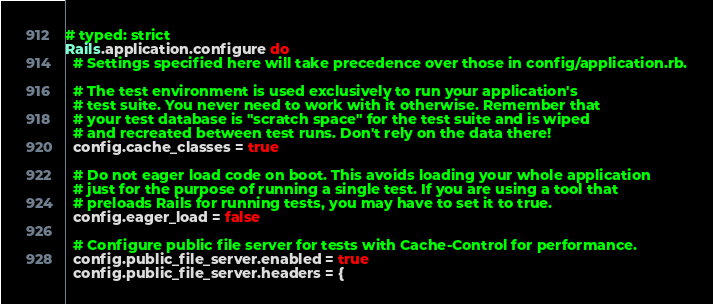<code> <loc_0><loc_0><loc_500><loc_500><_Ruby_># typed: strict
Rails.application.configure do
  # Settings specified here will take precedence over those in config/application.rb.

  # The test environment is used exclusively to run your application's
  # test suite. You never need to work with it otherwise. Remember that
  # your test database is "scratch space" for the test suite and is wiped
  # and recreated between test runs. Don't rely on the data there!
  config.cache_classes = true

  # Do not eager load code on boot. This avoids loading your whole application
  # just for the purpose of running a single test. If you are using a tool that
  # preloads Rails for running tests, you may have to set it to true.
  config.eager_load = false

  # Configure public file server for tests with Cache-Control for performance.
  config.public_file_server.enabled = true
  config.public_file_server.headers = {</code> 